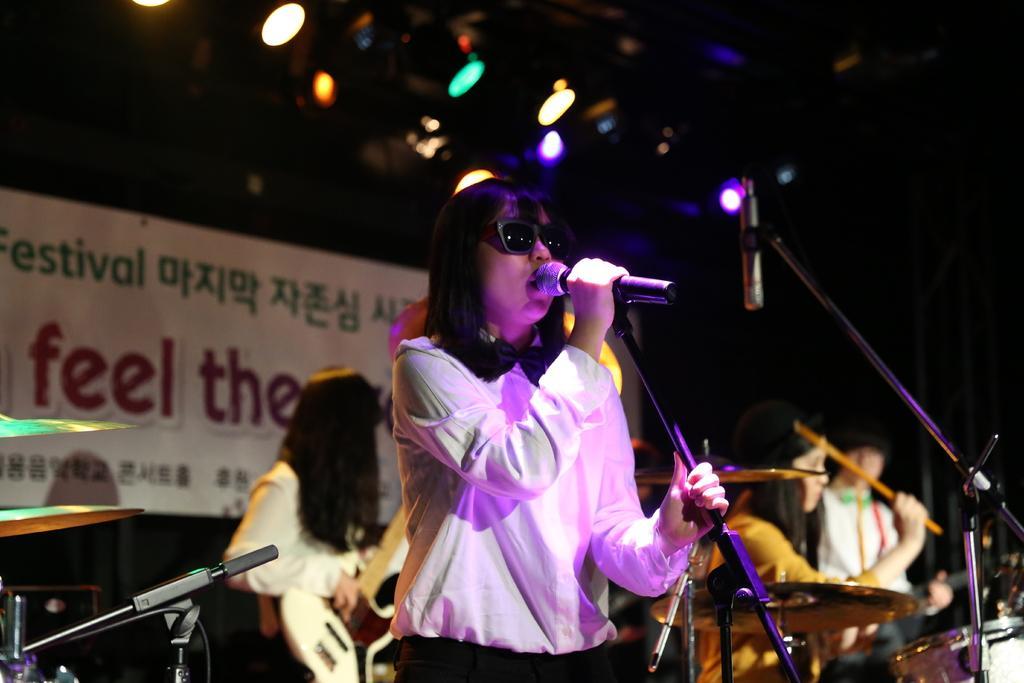Could you give a brief overview of what you see in this image? In this picture there is a woman wearing a white shirt, black trousers and she is holding a mike. Towards the left there is another mike. Towards the right there is a mike stand. Behind her there is a woman playing a guitar. Towards the right there is a woman and man. In the background there is a board and some text printed on it. In the top there are some lights. 